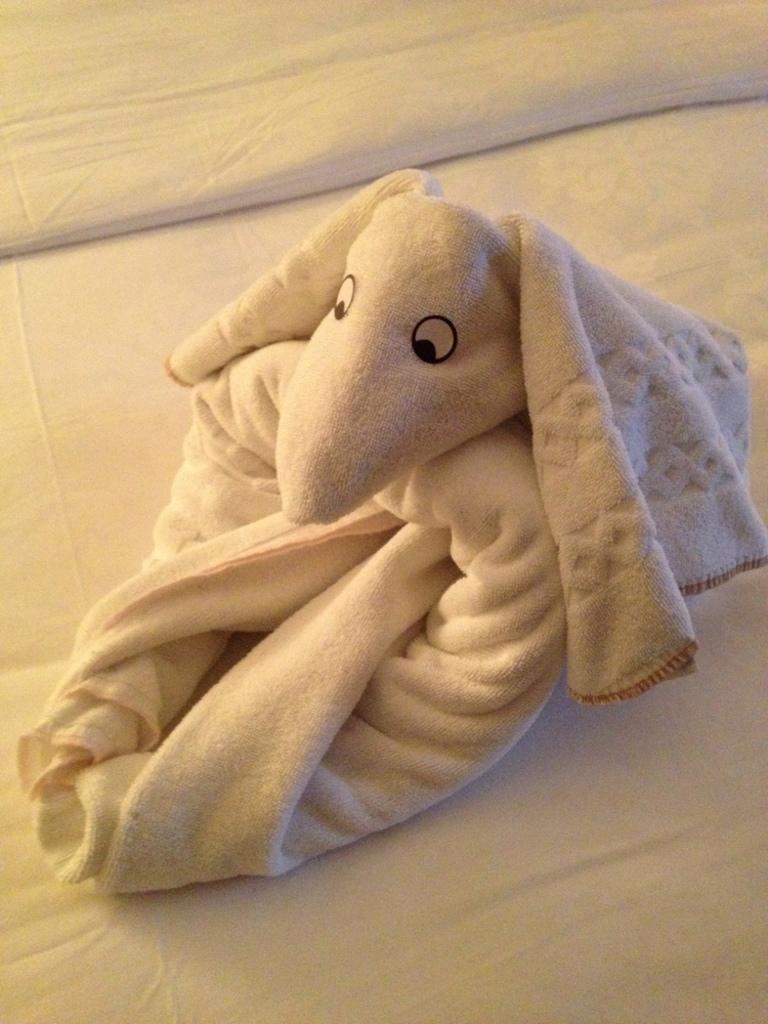In one or two sentences, can you explain what this image depicts? The picture consists a towel, blanket and bed. 